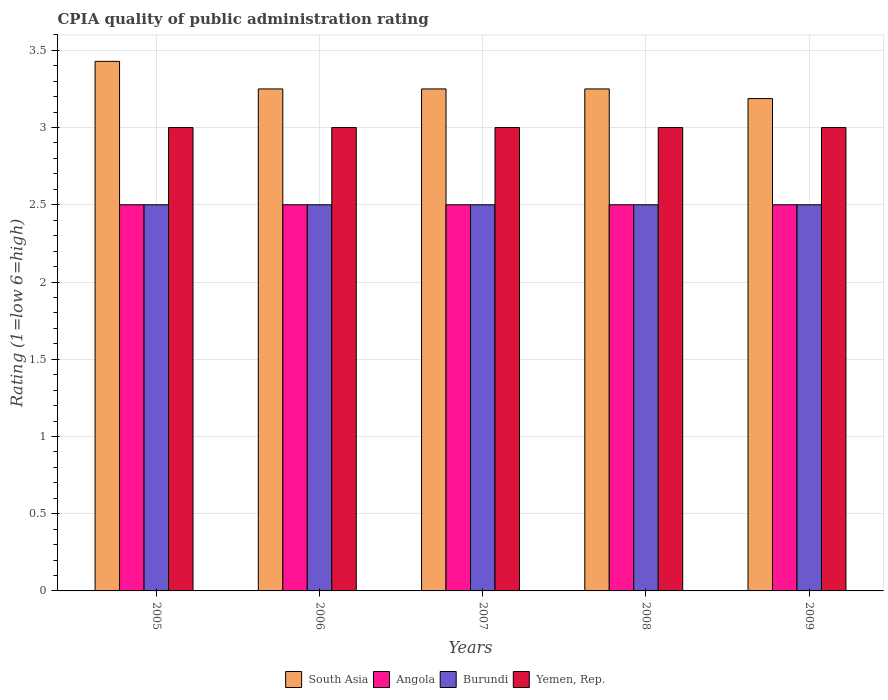How many groups of bars are there?
Keep it short and to the point. 5. How many bars are there on the 4th tick from the right?
Provide a succinct answer. 4. In how many cases, is the number of bars for a given year not equal to the number of legend labels?
Keep it short and to the point. 0. Across all years, what is the maximum CPIA rating in South Asia?
Offer a terse response. 3.43. Across all years, what is the minimum CPIA rating in South Asia?
Your answer should be compact. 3.19. What is the total CPIA rating in South Asia in the graph?
Provide a short and direct response. 16.37. What is the difference between the CPIA rating in South Asia in 2008 and the CPIA rating in Yemen, Rep. in 2009?
Offer a very short reply. 0.25. What is the average CPIA rating in Angola per year?
Provide a succinct answer. 2.5. In how many years, is the CPIA rating in South Asia greater than 1.1?
Give a very brief answer. 5. What is the ratio of the CPIA rating in Angola in 2006 to that in 2008?
Your answer should be very brief. 1. What is the difference between the highest and the second highest CPIA rating in South Asia?
Offer a terse response. 0.18. In how many years, is the CPIA rating in Yemen, Rep. greater than the average CPIA rating in Yemen, Rep. taken over all years?
Your answer should be very brief. 0. Is it the case that in every year, the sum of the CPIA rating in Yemen, Rep. and CPIA rating in Burundi is greater than the sum of CPIA rating in Angola and CPIA rating in South Asia?
Make the answer very short. Yes. What does the 4th bar from the left in 2005 represents?
Your response must be concise. Yemen, Rep. What does the 4th bar from the right in 2007 represents?
Your answer should be very brief. South Asia. How many bars are there?
Offer a terse response. 20. Are the values on the major ticks of Y-axis written in scientific E-notation?
Offer a very short reply. No. Does the graph contain any zero values?
Your answer should be very brief. No. Does the graph contain grids?
Your answer should be very brief. Yes. How many legend labels are there?
Your answer should be compact. 4. How are the legend labels stacked?
Ensure brevity in your answer.  Horizontal. What is the title of the graph?
Offer a very short reply. CPIA quality of public administration rating. Does "Trinidad and Tobago" appear as one of the legend labels in the graph?
Your answer should be compact. No. What is the Rating (1=low 6=high) in South Asia in 2005?
Offer a terse response. 3.43. What is the Rating (1=low 6=high) of Angola in 2005?
Make the answer very short. 2.5. What is the Rating (1=low 6=high) in South Asia in 2006?
Give a very brief answer. 3.25. What is the Rating (1=low 6=high) in Angola in 2006?
Your answer should be compact. 2.5. What is the Rating (1=low 6=high) of Yemen, Rep. in 2006?
Offer a terse response. 3. What is the Rating (1=low 6=high) in South Asia in 2007?
Make the answer very short. 3.25. What is the Rating (1=low 6=high) of Burundi in 2008?
Make the answer very short. 2.5. What is the Rating (1=low 6=high) of South Asia in 2009?
Give a very brief answer. 3.19. Across all years, what is the maximum Rating (1=low 6=high) of South Asia?
Offer a terse response. 3.43. Across all years, what is the maximum Rating (1=low 6=high) in Angola?
Offer a terse response. 2.5. Across all years, what is the maximum Rating (1=low 6=high) of Yemen, Rep.?
Your answer should be compact. 3. Across all years, what is the minimum Rating (1=low 6=high) in South Asia?
Give a very brief answer. 3.19. What is the total Rating (1=low 6=high) of South Asia in the graph?
Keep it short and to the point. 16.37. What is the difference between the Rating (1=low 6=high) in South Asia in 2005 and that in 2006?
Provide a short and direct response. 0.18. What is the difference between the Rating (1=low 6=high) of Burundi in 2005 and that in 2006?
Provide a short and direct response. 0. What is the difference between the Rating (1=low 6=high) of Yemen, Rep. in 2005 and that in 2006?
Ensure brevity in your answer.  0. What is the difference between the Rating (1=low 6=high) in South Asia in 2005 and that in 2007?
Your answer should be very brief. 0.18. What is the difference between the Rating (1=low 6=high) in Angola in 2005 and that in 2007?
Give a very brief answer. 0. What is the difference between the Rating (1=low 6=high) of Burundi in 2005 and that in 2007?
Offer a very short reply. 0. What is the difference between the Rating (1=low 6=high) in Yemen, Rep. in 2005 and that in 2007?
Keep it short and to the point. 0. What is the difference between the Rating (1=low 6=high) of South Asia in 2005 and that in 2008?
Provide a succinct answer. 0.18. What is the difference between the Rating (1=low 6=high) of Angola in 2005 and that in 2008?
Give a very brief answer. 0. What is the difference between the Rating (1=low 6=high) of South Asia in 2005 and that in 2009?
Offer a terse response. 0.24. What is the difference between the Rating (1=low 6=high) in Burundi in 2005 and that in 2009?
Make the answer very short. 0. What is the difference between the Rating (1=low 6=high) in Angola in 2006 and that in 2007?
Ensure brevity in your answer.  0. What is the difference between the Rating (1=low 6=high) of Yemen, Rep. in 2006 and that in 2007?
Your answer should be very brief. 0. What is the difference between the Rating (1=low 6=high) of Angola in 2006 and that in 2008?
Your answer should be compact. 0. What is the difference between the Rating (1=low 6=high) of South Asia in 2006 and that in 2009?
Keep it short and to the point. 0.06. What is the difference between the Rating (1=low 6=high) in Angola in 2007 and that in 2008?
Offer a terse response. 0. What is the difference between the Rating (1=low 6=high) in Yemen, Rep. in 2007 and that in 2008?
Ensure brevity in your answer.  0. What is the difference between the Rating (1=low 6=high) in South Asia in 2007 and that in 2009?
Provide a succinct answer. 0.06. What is the difference between the Rating (1=low 6=high) in Angola in 2007 and that in 2009?
Provide a succinct answer. 0. What is the difference between the Rating (1=low 6=high) in Yemen, Rep. in 2007 and that in 2009?
Make the answer very short. 0. What is the difference between the Rating (1=low 6=high) in South Asia in 2008 and that in 2009?
Provide a short and direct response. 0.06. What is the difference between the Rating (1=low 6=high) in Burundi in 2008 and that in 2009?
Offer a terse response. 0. What is the difference between the Rating (1=low 6=high) of South Asia in 2005 and the Rating (1=low 6=high) of Angola in 2006?
Keep it short and to the point. 0.93. What is the difference between the Rating (1=low 6=high) of South Asia in 2005 and the Rating (1=low 6=high) of Burundi in 2006?
Offer a terse response. 0.93. What is the difference between the Rating (1=low 6=high) of South Asia in 2005 and the Rating (1=low 6=high) of Yemen, Rep. in 2006?
Your response must be concise. 0.43. What is the difference between the Rating (1=low 6=high) of South Asia in 2005 and the Rating (1=low 6=high) of Angola in 2007?
Your answer should be very brief. 0.93. What is the difference between the Rating (1=low 6=high) of South Asia in 2005 and the Rating (1=low 6=high) of Yemen, Rep. in 2007?
Provide a short and direct response. 0.43. What is the difference between the Rating (1=low 6=high) in Burundi in 2005 and the Rating (1=low 6=high) in Yemen, Rep. in 2007?
Offer a terse response. -0.5. What is the difference between the Rating (1=low 6=high) in South Asia in 2005 and the Rating (1=low 6=high) in Burundi in 2008?
Keep it short and to the point. 0.93. What is the difference between the Rating (1=low 6=high) of South Asia in 2005 and the Rating (1=low 6=high) of Yemen, Rep. in 2008?
Your answer should be very brief. 0.43. What is the difference between the Rating (1=low 6=high) in Angola in 2005 and the Rating (1=low 6=high) in Burundi in 2008?
Your response must be concise. 0. What is the difference between the Rating (1=low 6=high) of South Asia in 2005 and the Rating (1=low 6=high) of Angola in 2009?
Offer a very short reply. 0.93. What is the difference between the Rating (1=low 6=high) of South Asia in 2005 and the Rating (1=low 6=high) of Yemen, Rep. in 2009?
Offer a terse response. 0.43. What is the difference between the Rating (1=low 6=high) in Angola in 2005 and the Rating (1=low 6=high) in Yemen, Rep. in 2009?
Your response must be concise. -0.5. What is the difference between the Rating (1=low 6=high) in Burundi in 2005 and the Rating (1=low 6=high) in Yemen, Rep. in 2009?
Your answer should be compact. -0.5. What is the difference between the Rating (1=low 6=high) of South Asia in 2006 and the Rating (1=low 6=high) of Angola in 2007?
Make the answer very short. 0.75. What is the difference between the Rating (1=low 6=high) in South Asia in 2006 and the Rating (1=low 6=high) in Angola in 2008?
Your answer should be very brief. 0.75. What is the difference between the Rating (1=low 6=high) in South Asia in 2006 and the Rating (1=low 6=high) in Yemen, Rep. in 2008?
Your answer should be compact. 0.25. What is the difference between the Rating (1=low 6=high) of South Asia in 2006 and the Rating (1=low 6=high) of Angola in 2009?
Make the answer very short. 0.75. What is the difference between the Rating (1=low 6=high) of South Asia in 2007 and the Rating (1=low 6=high) of Burundi in 2008?
Give a very brief answer. 0.75. What is the difference between the Rating (1=low 6=high) in South Asia in 2007 and the Rating (1=low 6=high) in Yemen, Rep. in 2008?
Your response must be concise. 0.25. What is the difference between the Rating (1=low 6=high) in Angola in 2007 and the Rating (1=low 6=high) in Yemen, Rep. in 2008?
Offer a very short reply. -0.5. What is the difference between the Rating (1=low 6=high) of Angola in 2007 and the Rating (1=low 6=high) of Burundi in 2009?
Provide a succinct answer. 0. What is the difference between the Rating (1=low 6=high) in Angola in 2007 and the Rating (1=low 6=high) in Yemen, Rep. in 2009?
Make the answer very short. -0.5. What is the difference between the Rating (1=low 6=high) of Burundi in 2007 and the Rating (1=low 6=high) of Yemen, Rep. in 2009?
Offer a very short reply. -0.5. What is the difference between the Rating (1=low 6=high) in South Asia in 2008 and the Rating (1=low 6=high) in Burundi in 2009?
Your answer should be compact. 0.75. What is the difference between the Rating (1=low 6=high) of Angola in 2008 and the Rating (1=low 6=high) of Burundi in 2009?
Make the answer very short. 0. What is the difference between the Rating (1=low 6=high) of Angola in 2008 and the Rating (1=low 6=high) of Yemen, Rep. in 2009?
Keep it short and to the point. -0.5. What is the difference between the Rating (1=low 6=high) in Burundi in 2008 and the Rating (1=low 6=high) in Yemen, Rep. in 2009?
Make the answer very short. -0.5. What is the average Rating (1=low 6=high) in South Asia per year?
Your response must be concise. 3.27. What is the average Rating (1=low 6=high) of Burundi per year?
Provide a short and direct response. 2.5. In the year 2005, what is the difference between the Rating (1=low 6=high) of South Asia and Rating (1=low 6=high) of Burundi?
Keep it short and to the point. 0.93. In the year 2005, what is the difference between the Rating (1=low 6=high) of South Asia and Rating (1=low 6=high) of Yemen, Rep.?
Ensure brevity in your answer.  0.43. In the year 2005, what is the difference between the Rating (1=low 6=high) in Angola and Rating (1=low 6=high) in Yemen, Rep.?
Make the answer very short. -0.5. In the year 2005, what is the difference between the Rating (1=low 6=high) in Burundi and Rating (1=low 6=high) in Yemen, Rep.?
Your answer should be very brief. -0.5. In the year 2006, what is the difference between the Rating (1=low 6=high) in South Asia and Rating (1=low 6=high) in Angola?
Your answer should be compact. 0.75. In the year 2006, what is the difference between the Rating (1=low 6=high) of South Asia and Rating (1=low 6=high) of Burundi?
Your answer should be very brief. 0.75. In the year 2006, what is the difference between the Rating (1=low 6=high) of Angola and Rating (1=low 6=high) of Burundi?
Offer a very short reply. 0. In the year 2006, what is the difference between the Rating (1=low 6=high) of Angola and Rating (1=low 6=high) of Yemen, Rep.?
Offer a very short reply. -0.5. In the year 2007, what is the difference between the Rating (1=low 6=high) of South Asia and Rating (1=low 6=high) of Yemen, Rep.?
Your answer should be very brief. 0.25. In the year 2007, what is the difference between the Rating (1=low 6=high) in Angola and Rating (1=low 6=high) in Burundi?
Ensure brevity in your answer.  0. In the year 2008, what is the difference between the Rating (1=low 6=high) in South Asia and Rating (1=low 6=high) in Angola?
Ensure brevity in your answer.  0.75. In the year 2008, what is the difference between the Rating (1=low 6=high) in South Asia and Rating (1=low 6=high) in Burundi?
Keep it short and to the point. 0.75. In the year 2009, what is the difference between the Rating (1=low 6=high) in South Asia and Rating (1=low 6=high) in Angola?
Give a very brief answer. 0.69. In the year 2009, what is the difference between the Rating (1=low 6=high) in South Asia and Rating (1=low 6=high) in Burundi?
Offer a very short reply. 0.69. In the year 2009, what is the difference between the Rating (1=low 6=high) of South Asia and Rating (1=low 6=high) of Yemen, Rep.?
Your response must be concise. 0.19. In the year 2009, what is the difference between the Rating (1=low 6=high) in Angola and Rating (1=low 6=high) in Burundi?
Provide a short and direct response. 0. In the year 2009, what is the difference between the Rating (1=low 6=high) in Angola and Rating (1=low 6=high) in Yemen, Rep.?
Provide a succinct answer. -0.5. In the year 2009, what is the difference between the Rating (1=low 6=high) in Burundi and Rating (1=low 6=high) in Yemen, Rep.?
Provide a short and direct response. -0.5. What is the ratio of the Rating (1=low 6=high) of South Asia in 2005 to that in 2006?
Give a very brief answer. 1.05. What is the ratio of the Rating (1=low 6=high) in Angola in 2005 to that in 2006?
Offer a terse response. 1. What is the ratio of the Rating (1=low 6=high) of Yemen, Rep. in 2005 to that in 2006?
Ensure brevity in your answer.  1. What is the ratio of the Rating (1=low 6=high) in South Asia in 2005 to that in 2007?
Keep it short and to the point. 1.05. What is the ratio of the Rating (1=low 6=high) of Angola in 2005 to that in 2007?
Provide a short and direct response. 1. What is the ratio of the Rating (1=low 6=high) of Yemen, Rep. in 2005 to that in 2007?
Provide a succinct answer. 1. What is the ratio of the Rating (1=low 6=high) in South Asia in 2005 to that in 2008?
Your answer should be very brief. 1.05. What is the ratio of the Rating (1=low 6=high) of Angola in 2005 to that in 2008?
Keep it short and to the point. 1. What is the ratio of the Rating (1=low 6=high) of Burundi in 2005 to that in 2008?
Offer a terse response. 1. What is the ratio of the Rating (1=low 6=high) in South Asia in 2005 to that in 2009?
Offer a very short reply. 1.08. What is the ratio of the Rating (1=low 6=high) of Angola in 2005 to that in 2009?
Offer a terse response. 1. What is the ratio of the Rating (1=low 6=high) in Yemen, Rep. in 2005 to that in 2009?
Your answer should be very brief. 1. What is the ratio of the Rating (1=low 6=high) of Burundi in 2006 to that in 2007?
Your answer should be compact. 1. What is the ratio of the Rating (1=low 6=high) in South Asia in 2006 to that in 2008?
Offer a terse response. 1. What is the ratio of the Rating (1=low 6=high) of Burundi in 2006 to that in 2008?
Give a very brief answer. 1. What is the ratio of the Rating (1=low 6=high) in Yemen, Rep. in 2006 to that in 2008?
Ensure brevity in your answer.  1. What is the ratio of the Rating (1=low 6=high) in South Asia in 2006 to that in 2009?
Your answer should be compact. 1.02. What is the ratio of the Rating (1=low 6=high) in Burundi in 2006 to that in 2009?
Your answer should be very brief. 1. What is the ratio of the Rating (1=low 6=high) in Yemen, Rep. in 2006 to that in 2009?
Your answer should be compact. 1. What is the ratio of the Rating (1=low 6=high) in South Asia in 2007 to that in 2008?
Provide a succinct answer. 1. What is the ratio of the Rating (1=low 6=high) of Yemen, Rep. in 2007 to that in 2008?
Offer a very short reply. 1. What is the ratio of the Rating (1=low 6=high) in South Asia in 2007 to that in 2009?
Keep it short and to the point. 1.02. What is the ratio of the Rating (1=low 6=high) in Yemen, Rep. in 2007 to that in 2009?
Make the answer very short. 1. What is the ratio of the Rating (1=low 6=high) in South Asia in 2008 to that in 2009?
Make the answer very short. 1.02. What is the ratio of the Rating (1=low 6=high) in Angola in 2008 to that in 2009?
Ensure brevity in your answer.  1. What is the ratio of the Rating (1=low 6=high) in Yemen, Rep. in 2008 to that in 2009?
Give a very brief answer. 1. What is the difference between the highest and the second highest Rating (1=low 6=high) in South Asia?
Ensure brevity in your answer.  0.18. What is the difference between the highest and the second highest Rating (1=low 6=high) of Angola?
Your answer should be compact. 0. What is the difference between the highest and the lowest Rating (1=low 6=high) of South Asia?
Keep it short and to the point. 0.24. What is the difference between the highest and the lowest Rating (1=low 6=high) in Burundi?
Make the answer very short. 0. 